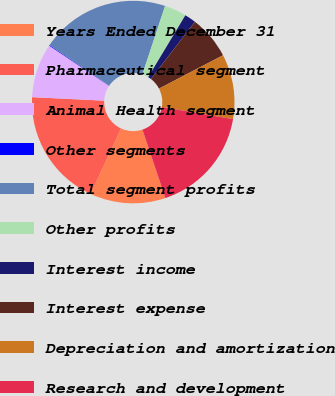<chart> <loc_0><loc_0><loc_500><loc_500><pie_chart><fcel>Years Ended December 31<fcel>Pharmaceutical segment<fcel>Animal Health segment<fcel>Other segments<fcel>Total segment profits<fcel>Other profits<fcel>Interest income<fcel>Interest expense<fcel>Depreciation and amortization<fcel>Research and development<nl><fcel>12.05%<fcel>18.87%<fcel>8.64%<fcel>0.11%<fcel>20.58%<fcel>3.52%<fcel>1.81%<fcel>6.93%<fcel>10.34%<fcel>17.16%<nl></chart> 